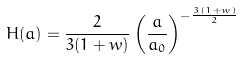<formula> <loc_0><loc_0><loc_500><loc_500>H ( a ) = \frac { 2 } { 3 ( 1 + w ) } \left ( \frac { a } { a _ { 0 } } \right ) ^ { - \frac { 3 ( 1 + w ) } { 2 } }</formula> 